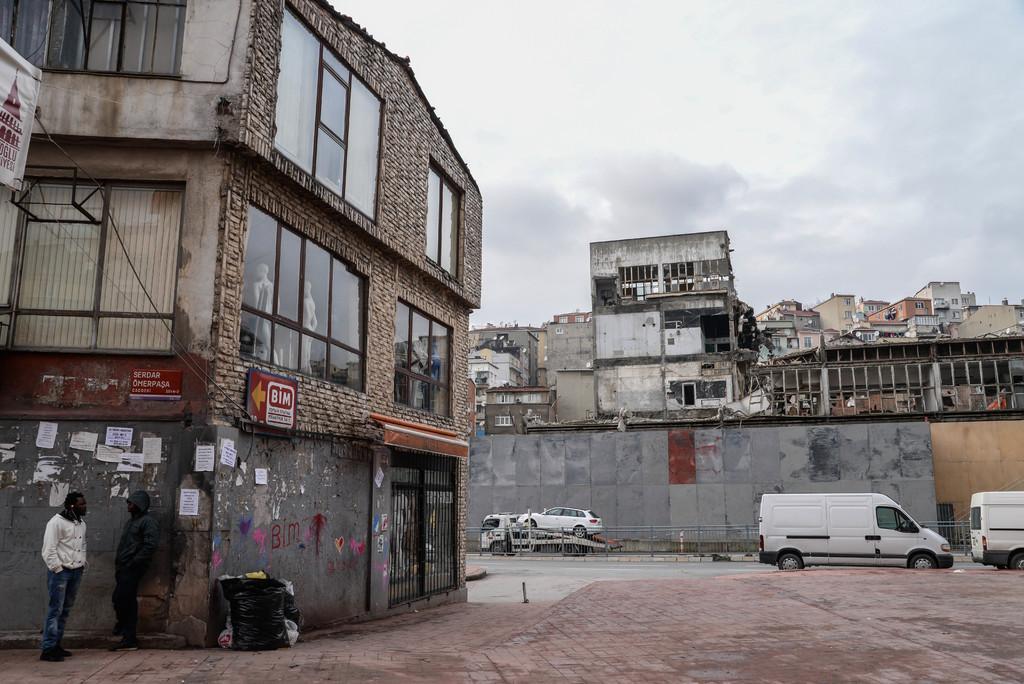In one or two sentences, can you explain what this image depicts? In the image there is a building and beside the building two men were standing and talking to each other, in front of the building few vehicles are moving on the road. Behind the road there is a wall and above the wall there are many houses and buildings. 